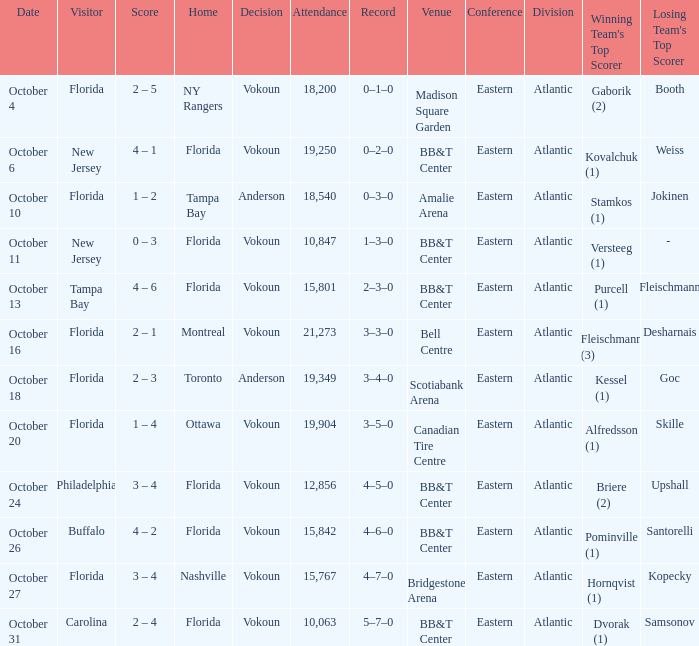What was the score on October 13? 4 – 6. 